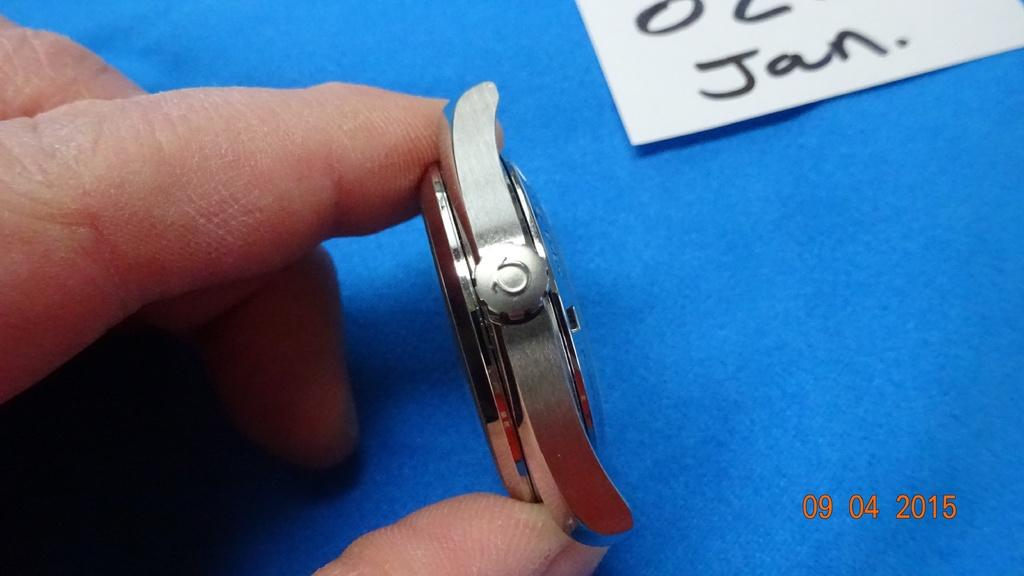<image>
Describe the image concisely. a hand holding a metal object near a sign with Jan on it 